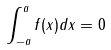<formula> <loc_0><loc_0><loc_500><loc_500>\int _ { - a } ^ { a } f ( x ) d x = 0</formula> 